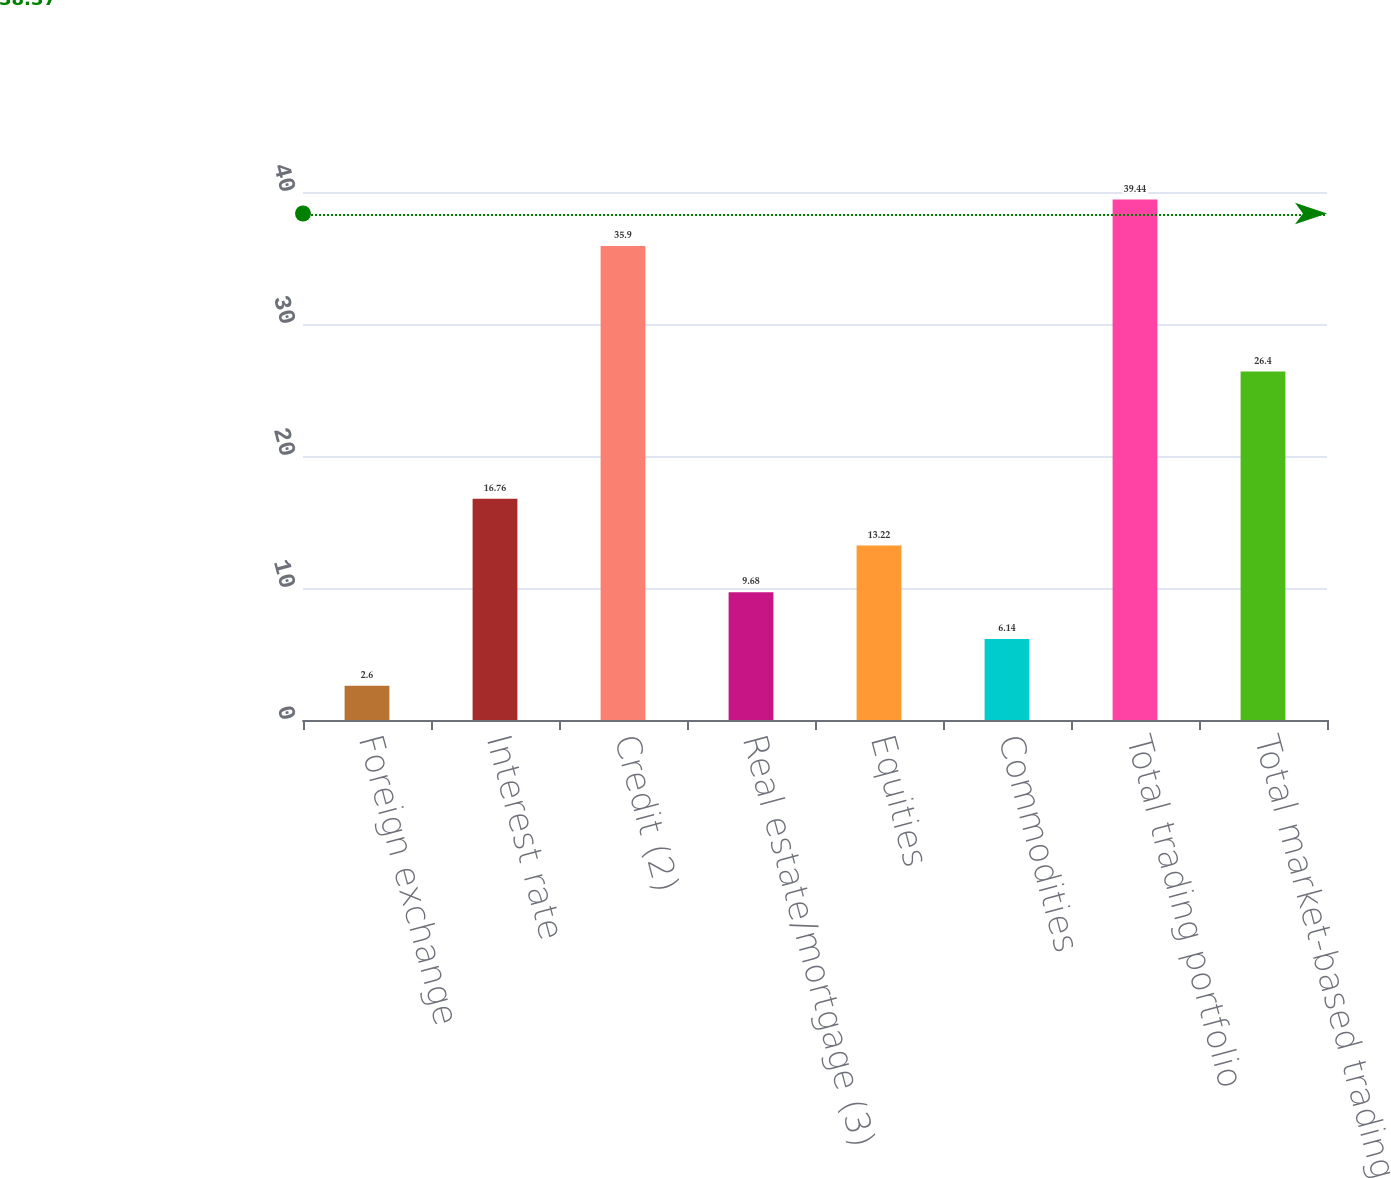Convert chart to OTSL. <chart><loc_0><loc_0><loc_500><loc_500><bar_chart><fcel>Foreign exchange<fcel>Interest rate<fcel>Credit (2)<fcel>Real estate/mortgage (3)<fcel>Equities<fcel>Commodities<fcel>Total trading portfolio<fcel>Total market-based trading<nl><fcel>2.6<fcel>16.76<fcel>35.9<fcel>9.68<fcel>13.22<fcel>6.14<fcel>39.44<fcel>26.4<nl></chart> 